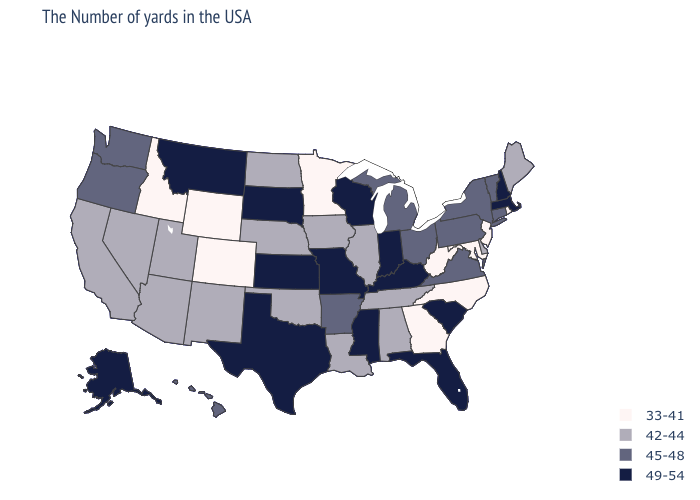Does the map have missing data?
Be succinct. No. Does Texas have the highest value in the South?
Short answer required. Yes. Name the states that have a value in the range 33-41?
Give a very brief answer. Rhode Island, New Jersey, Maryland, North Carolina, West Virginia, Georgia, Minnesota, Wyoming, Colorado, Idaho. Name the states that have a value in the range 33-41?
Write a very short answer. Rhode Island, New Jersey, Maryland, North Carolina, West Virginia, Georgia, Minnesota, Wyoming, Colorado, Idaho. Name the states that have a value in the range 49-54?
Write a very short answer. Massachusetts, New Hampshire, South Carolina, Florida, Kentucky, Indiana, Wisconsin, Mississippi, Missouri, Kansas, Texas, South Dakota, Montana, Alaska. What is the value of Rhode Island?
Keep it brief. 33-41. What is the value of Wyoming?
Quick response, please. 33-41. What is the lowest value in the USA?
Answer briefly. 33-41. What is the lowest value in states that border Vermont?
Answer briefly. 45-48. Does Pennsylvania have a higher value than West Virginia?
Answer briefly. Yes. Does North Carolina have the same value as Montana?
Be succinct. No. Name the states that have a value in the range 33-41?
Quick response, please. Rhode Island, New Jersey, Maryland, North Carolina, West Virginia, Georgia, Minnesota, Wyoming, Colorado, Idaho. Which states have the lowest value in the South?
Give a very brief answer. Maryland, North Carolina, West Virginia, Georgia. What is the value of Missouri?
Write a very short answer. 49-54. Among the states that border Iowa , which have the highest value?
Short answer required. Wisconsin, Missouri, South Dakota. 